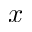<formula> <loc_0><loc_0><loc_500><loc_500>x</formula> 